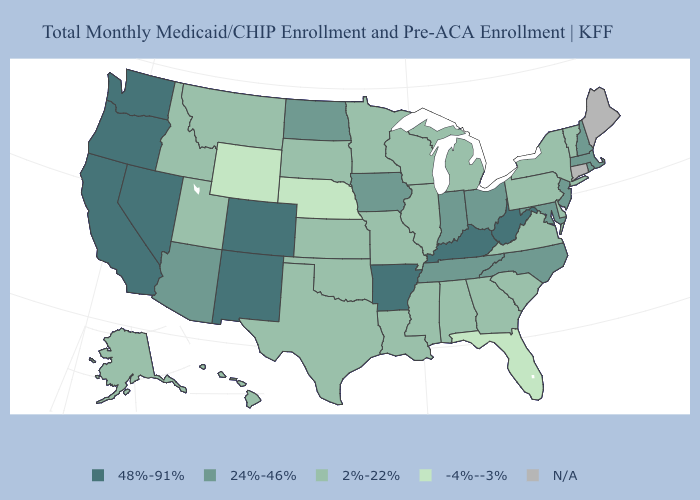Name the states that have a value in the range 2%-22%?
Write a very short answer. Alabama, Alaska, Delaware, Georgia, Hawaii, Idaho, Illinois, Kansas, Louisiana, Michigan, Minnesota, Mississippi, Missouri, Montana, New York, Oklahoma, Pennsylvania, South Carolina, South Dakota, Texas, Utah, Vermont, Virginia, Wisconsin. What is the value of Georgia?
Give a very brief answer. 2%-22%. Which states have the highest value in the USA?
Concise answer only. Arkansas, California, Colorado, Kentucky, Nevada, New Mexico, Oregon, Washington, West Virginia. What is the value of Colorado?
Concise answer only. 48%-91%. What is the value of Arizona?
Keep it brief. 24%-46%. Is the legend a continuous bar?
Quick response, please. No. Which states have the lowest value in the USA?
Concise answer only. Florida, Nebraska, Wyoming. Which states have the lowest value in the Northeast?
Keep it brief. New York, Pennsylvania, Vermont. Among the states that border California , does Arizona have the lowest value?
Give a very brief answer. Yes. Does Indiana have the highest value in the MidWest?
Give a very brief answer. Yes. What is the lowest value in the USA?
Short answer required. -4%--3%. Name the states that have a value in the range 24%-46%?
Write a very short answer. Arizona, Indiana, Iowa, Maryland, Massachusetts, New Hampshire, New Jersey, North Carolina, North Dakota, Ohio, Rhode Island, Tennessee. Does Florida have the lowest value in the USA?
Answer briefly. Yes. 